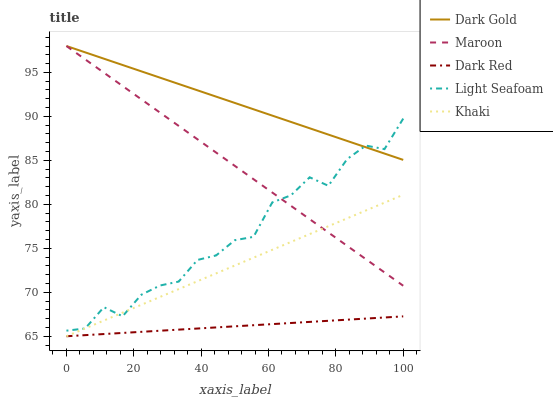Does Dark Red have the minimum area under the curve?
Answer yes or no. Yes. Does Light Seafoam have the minimum area under the curve?
Answer yes or no. No. Does Light Seafoam have the maximum area under the curve?
Answer yes or no. No. Is Dark Gold the smoothest?
Answer yes or no. Yes. Is Light Seafoam the roughest?
Answer yes or no. Yes. Is Khaki the smoothest?
Answer yes or no. No. Is Khaki the roughest?
Answer yes or no. No. Does Light Seafoam have the lowest value?
Answer yes or no. No. Does Light Seafoam have the highest value?
Answer yes or no. No. Is Dark Red less than Light Seafoam?
Answer yes or no. Yes. Is Light Seafoam greater than Dark Red?
Answer yes or no. Yes. Does Dark Red intersect Light Seafoam?
Answer yes or no. No. 